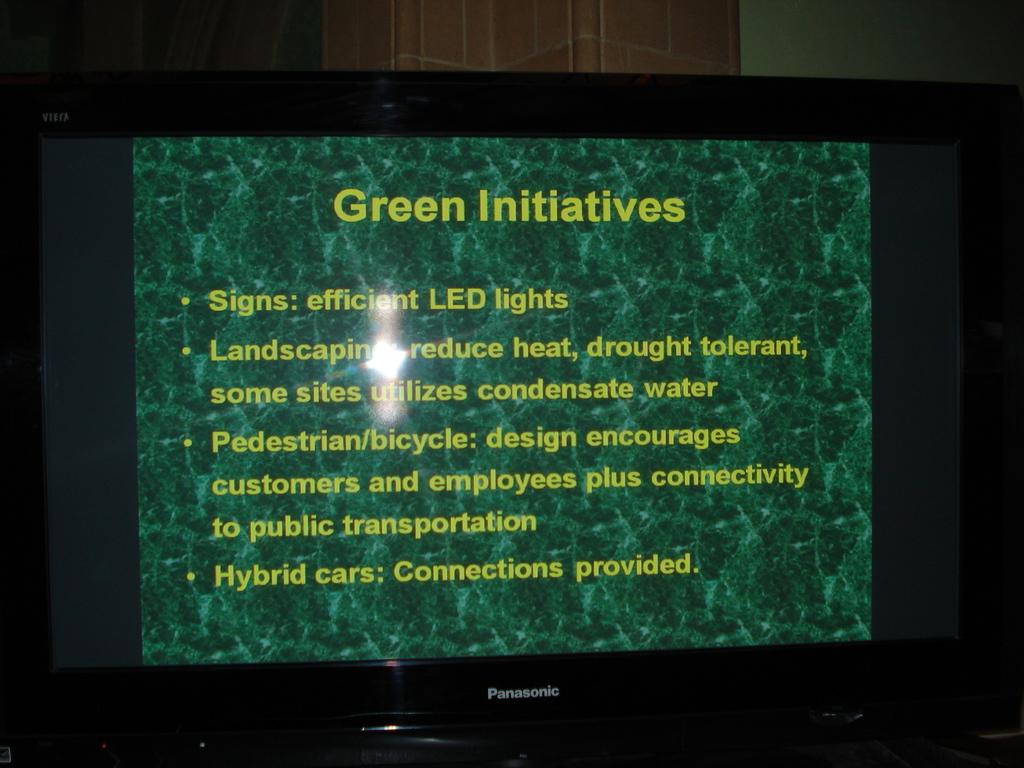What is the headline of this presentation?
Provide a succinct answer. Green initiatives. What color is the text in this image?
Give a very brief answer. Yellow. 